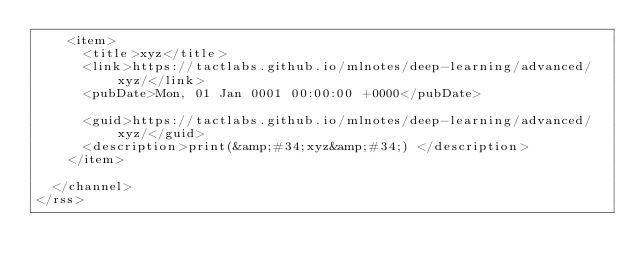Convert code to text. <code><loc_0><loc_0><loc_500><loc_500><_XML_>    <item>
      <title>xyz</title>
      <link>https://tactlabs.github.io/mlnotes/deep-learning/advanced/xyz/</link>
      <pubDate>Mon, 01 Jan 0001 00:00:00 +0000</pubDate>
      
      <guid>https://tactlabs.github.io/mlnotes/deep-learning/advanced/xyz/</guid>
      <description>print(&amp;#34;xyz&amp;#34;) </description>
    </item>
    
  </channel>
</rss></code> 